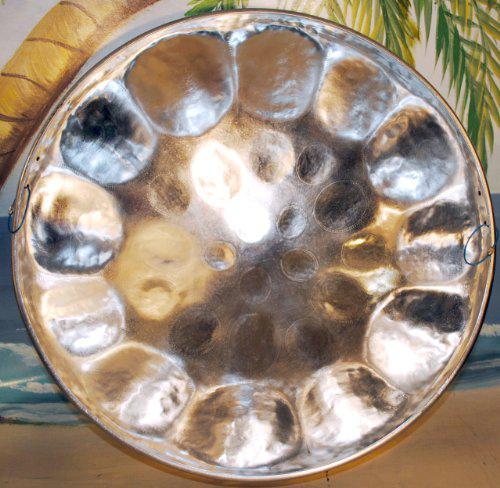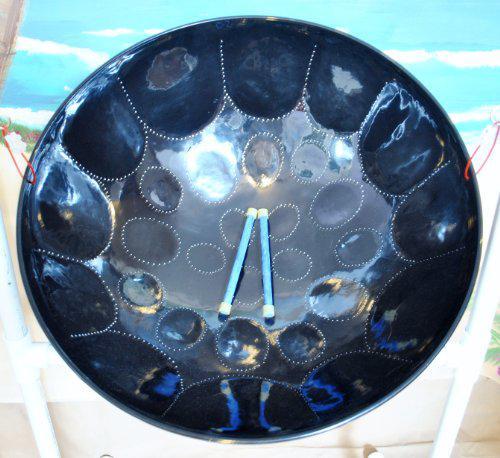The first image is the image on the left, the second image is the image on the right. Examine the images to the left and right. Is the description "There are two drum stick laying in the middle of an inverted metal drum." accurate? Answer yes or no. Yes. The first image is the image on the left, the second image is the image on the right. For the images shown, is this caption "The right image shows the interior of a concave metal drum, with a pair of drumsticks in its bowl." true? Answer yes or no. Yes. 